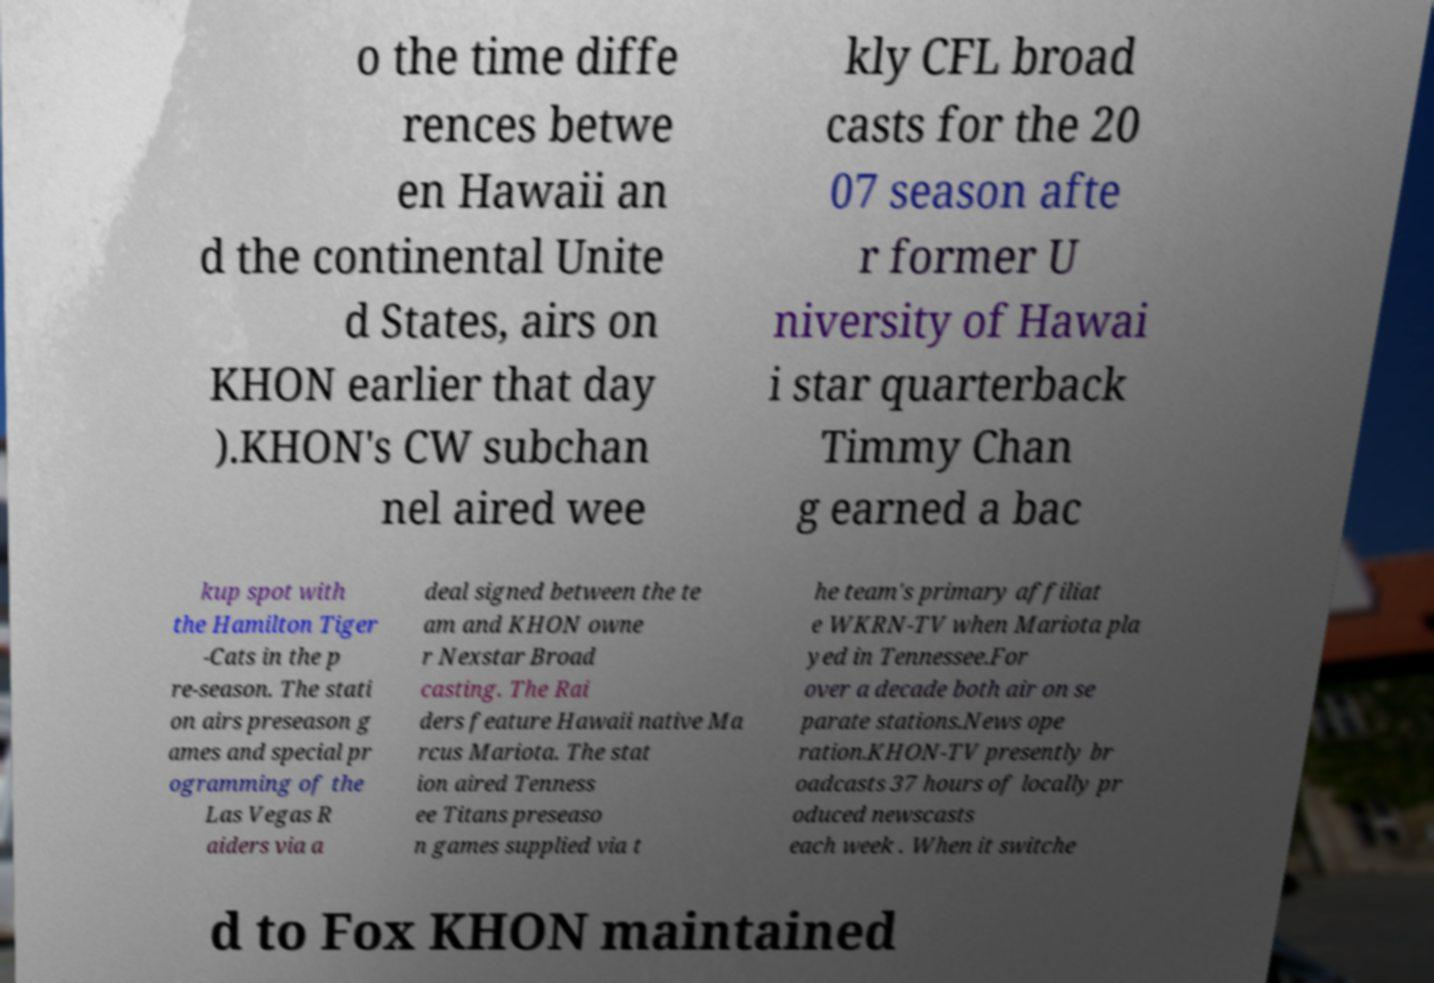For documentation purposes, I need the text within this image transcribed. Could you provide that? o the time diffe rences betwe en Hawaii an d the continental Unite d States, airs on KHON earlier that day ).KHON's CW subchan nel aired wee kly CFL broad casts for the 20 07 season afte r former U niversity of Hawai i star quarterback Timmy Chan g earned a bac kup spot with the Hamilton Tiger -Cats in the p re-season. The stati on airs preseason g ames and special pr ogramming of the Las Vegas R aiders via a deal signed between the te am and KHON owne r Nexstar Broad casting. The Rai ders feature Hawaii native Ma rcus Mariota. The stat ion aired Tenness ee Titans preseaso n games supplied via t he team's primary affiliat e WKRN-TV when Mariota pla yed in Tennessee.For over a decade both air on se parate stations.News ope ration.KHON-TV presently br oadcasts 37 hours of locally pr oduced newscasts each week . When it switche d to Fox KHON maintained 